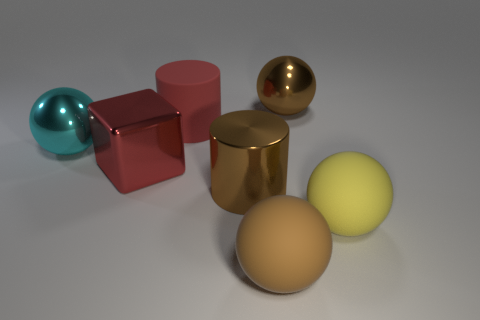Can you guess what the purpose of these objects might be? These objects appear to be conceptual representations rather than functional items. They could be used for educational purposes to illustrate geometry, physics concepts like light and reflections, or for artistic purposes in graphic design and visualization. 